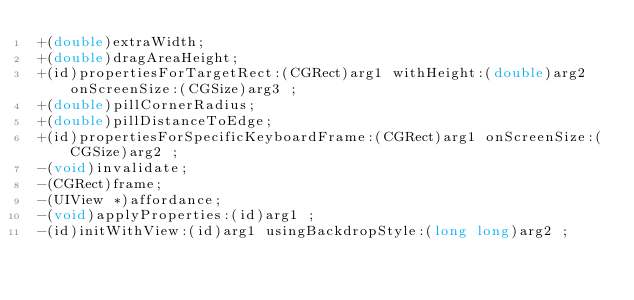Convert code to text. <code><loc_0><loc_0><loc_500><loc_500><_C_>+(double)extraWidth;
+(double)dragAreaHeight;
+(id)propertiesForTargetRect:(CGRect)arg1 withHeight:(double)arg2 onScreenSize:(CGSize)arg3 ;
+(double)pillCornerRadius;
+(double)pillDistanceToEdge;
+(id)propertiesForSpecificKeyboardFrame:(CGRect)arg1 onScreenSize:(CGSize)arg2 ;
-(void)invalidate;
-(CGRect)frame;
-(UIView *)affordance;
-(void)applyProperties:(id)arg1 ;
-(id)initWithView:(id)arg1 usingBackdropStyle:(long long)arg2 ;</code> 